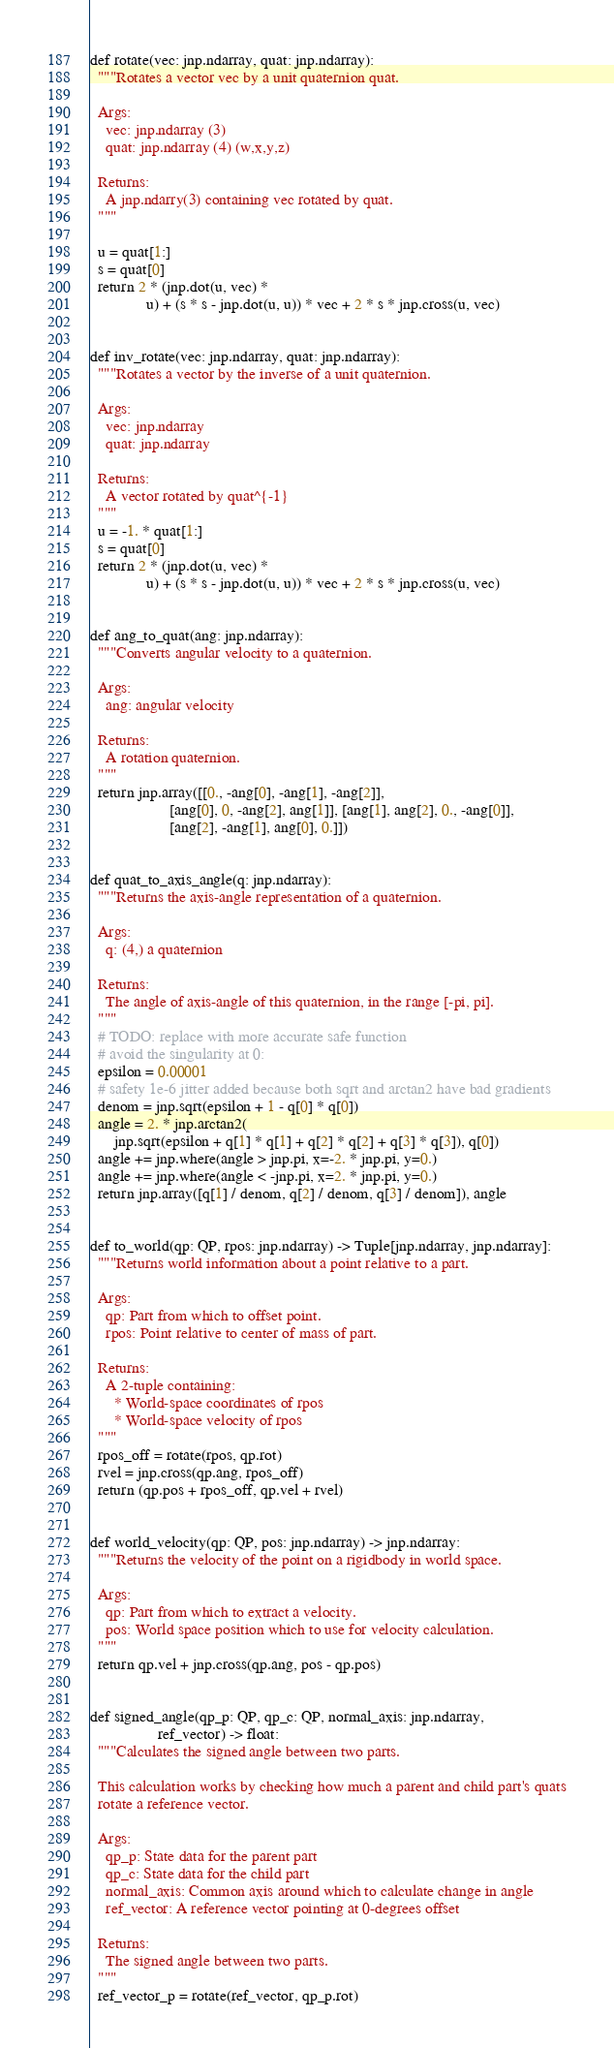<code> <loc_0><loc_0><loc_500><loc_500><_Python_>def rotate(vec: jnp.ndarray, quat: jnp.ndarray):
  """Rotates a vector vec by a unit quaternion quat.

  Args:
    vec: jnp.ndarray (3)
    quat: jnp.ndarray (4) (w,x,y,z)

  Returns:
    A jnp.ndarry(3) containing vec rotated by quat.
  """

  u = quat[1:]
  s = quat[0]
  return 2 * (jnp.dot(u, vec) *
              u) + (s * s - jnp.dot(u, u)) * vec + 2 * s * jnp.cross(u, vec)


def inv_rotate(vec: jnp.ndarray, quat: jnp.ndarray):
  """Rotates a vector by the inverse of a unit quaternion.

  Args:
    vec: jnp.ndarray
    quat: jnp.ndarray

  Returns:
    A vector rotated by quat^{-1}
  """
  u = -1. * quat[1:]
  s = quat[0]
  return 2 * (jnp.dot(u, vec) *
              u) + (s * s - jnp.dot(u, u)) * vec + 2 * s * jnp.cross(u, vec)


def ang_to_quat(ang: jnp.ndarray):
  """Converts angular velocity to a quaternion.

  Args:
    ang: angular velocity

  Returns:
    A rotation quaternion.
  """
  return jnp.array([[0., -ang[0], -ang[1], -ang[2]],
                    [ang[0], 0, -ang[2], ang[1]], [ang[1], ang[2], 0., -ang[0]],
                    [ang[2], -ang[1], ang[0], 0.]])


def quat_to_axis_angle(q: jnp.ndarray):
  """Returns the axis-angle representation of a quaternion.

  Args:
    q: (4,) a quaternion

  Returns:
    The angle of axis-angle of this quaternion, in the range [-pi, pi].
  """
  # TODO: replace with more accurate safe function
  # avoid the singularity at 0:
  epsilon = 0.00001
  # safety 1e-6 jitter added because both sqrt and arctan2 have bad gradients
  denom = jnp.sqrt(epsilon + 1 - q[0] * q[0])
  angle = 2. * jnp.arctan2(
      jnp.sqrt(epsilon + q[1] * q[1] + q[2] * q[2] + q[3] * q[3]), q[0])
  angle += jnp.where(angle > jnp.pi, x=-2. * jnp.pi, y=0.)
  angle += jnp.where(angle < -jnp.pi, x=2. * jnp.pi, y=0.)
  return jnp.array([q[1] / denom, q[2] / denom, q[3] / denom]), angle


def to_world(qp: QP, rpos: jnp.ndarray) -> Tuple[jnp.ndarray, jnp.ndarray]:
  """Returns world information about a point relative to a part.

  Args:
    qp: Part from which to offset point.
    rpos: Point relative to center of mass of part.

  Returns:
    A 2-tuple containing:
      * World-space coordinates of rpos
      * World-space velocity of rpos
  """
  rpos_off = rotate(rpos, qp.rot)
  rvel = jnp.cross(qp.ang, rpos_off)
  return (qp.pos + rpos_off, qp.vel + rvel)


def world_velocity(qp: QP, pos: jnp.ndarray) -> jnp.ndarray:
  """Returns the velocity of the point on a rigidbody in world space.

  Args:
    qp: Part from which to extract a velocity.
    pos: World space position which to use for velocity calculation.
  """
  return qp.vel + jnp.cross(qp.ang, pos - qp.pos)


def signed_angle(qp_p: QP, qp_c: QP, normal_axis: jnp.ndarray,
                 ref_vector) -> float:
  """Calculates the signed angle between two parts.

  This calculation works by checking how much a parent and child part's quats
  rotate a reference vector.

  Args:
    qp_p: State data for the parent part
    qp_c: State data for the child part
    normal_axis: Common axis around which to calculate change in angle
    ref_vector: A reference vector pointing at 0-degrees offset

  Returns:
    The signed angle between two parts.
  """
  ref_vector_p = rotate(ref_vector, qp_p.rot)</code> 